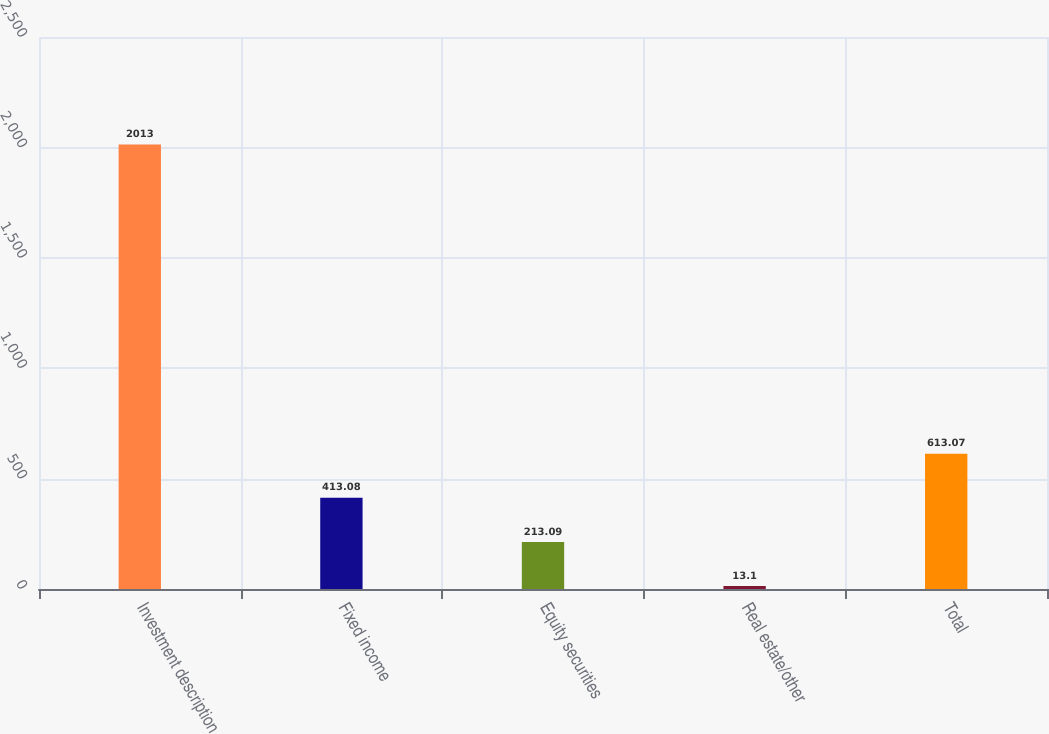Convert chart. <chart><loc_0><loc_0><loc_500><loc_500><bar_chart><fcel>Investment description<fcel>Fixed income<fcel>Equity securities<fcel>Real estate/other<fcel>Total<nl><fcel>2013<fcel>413.08<fcel>213.09<fcel>13.1<fcel>613.07<nl></chart> 